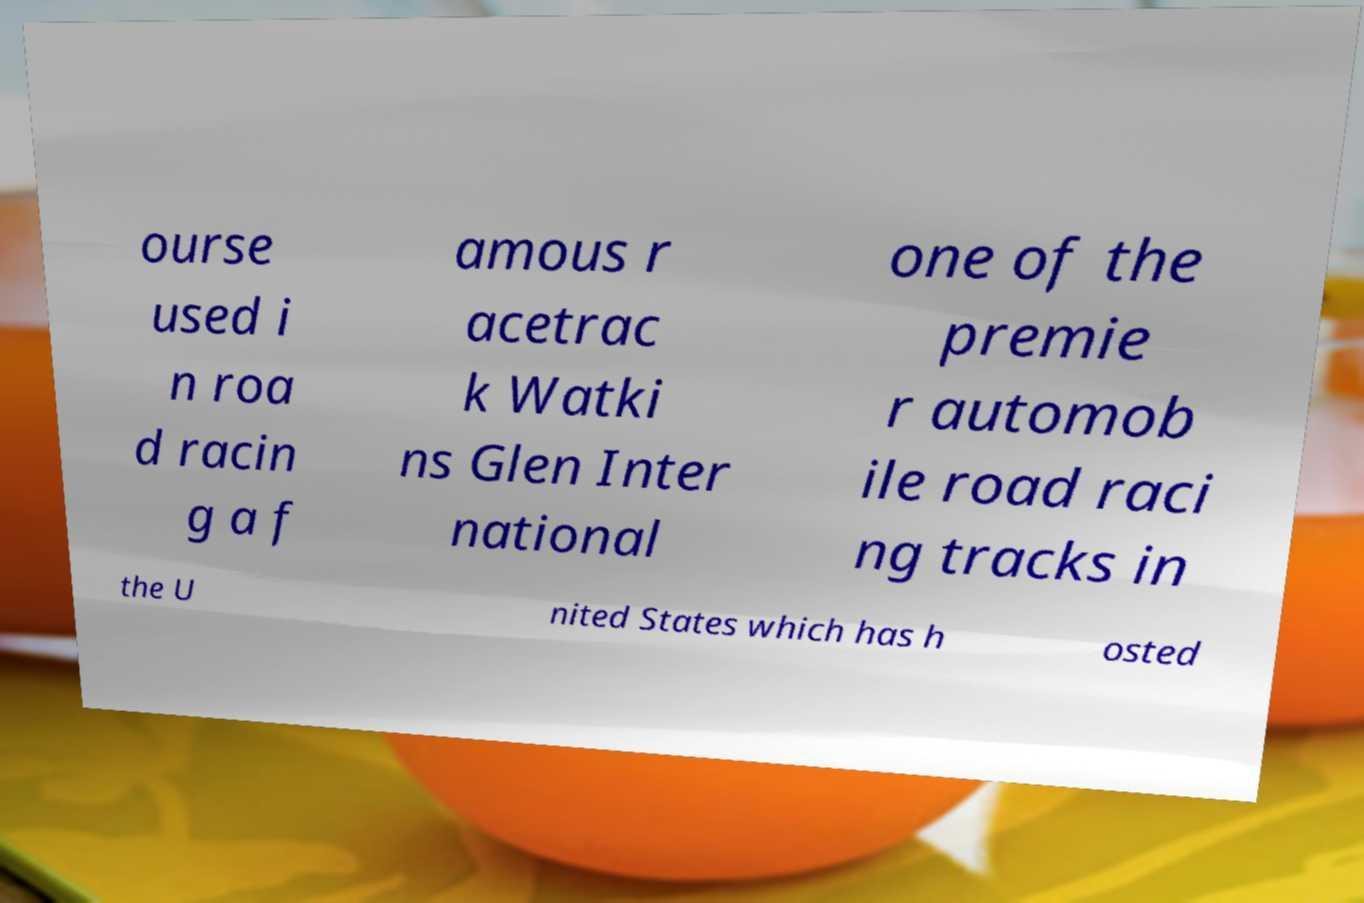What messages or text are displayed in this image? I need them in a readable, typed format. ourse used i n roa d racin g a f amous r acetrac k Watki ns Glen Inter national one of the premie r automob ile road raci ng tracks in the U nited States which has h osted 